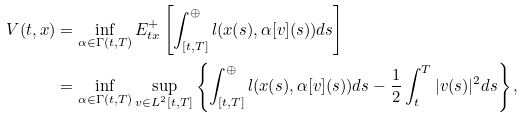<formula> <loc_0><loc_0><loc_500><loc_500>V ( t , x ) & = \inf _ { \alpha \in \Gamma ( t , T ) } E ^ { + } _ { t x } \left [ \int _ { [ t , T ] } ^ { \oplus } l ( x ( s ) , \alpha [ v ] ( s ) ) d s \right ] \\ & = \inf _ { \alpha \in \Gamma ( t , T ) } \sup _ { v \in L ^ { 2 } [ t , T ] } \left \{ \int _ { [ t , T ] } ^ { \oplus } l ( x ( s ) , \alpha [ v ] ( s ) ) d s - \frac { 1 } { 2 } \int _ { t } ^ { T } | v ( s ) | ^ { 2 } d s \right \} ,</formula> 